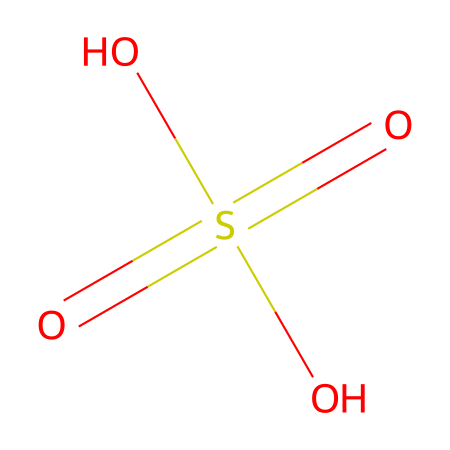What is the name of this chemical? The SMILES representation corresponds to the structural formula of sulfuric acid, which is well-known in chemistry.
Answer: sulfuric acid How many oxygen atoms are present in this chemical? Analyzing the SMILES, there are four oxygen atoms indicated (O= and O- in the representation).
Answer: four What is the total number of hydrogen atoms in this chemical? The structure shows two hydroxyl groups (–OH), which indicates there are two hydrogen atoms connected to the oxygen atoms in addition to the oxygens already present.
Answer: two What type of acid is represented by this chemical? The presence of multiple oxygen atoms bonded to sulfur and the hydroxyl groups indicates that this is a strong mineral acid known for its corrosive properties.
Answer: strong acid How does the presence of sulfur affect the reactivity of this chemical? Sulfur typically forms strong bonds with oxygen, leading to high acidity and reactivity; the SO4 structure shows this reactive capability.
Answer: increases reactivity What is this chemical commonly used for in industry? This acid is extensively utilized in several industrial applications including cleaning processes and manufacturing, due to its strong dehydrating properties.
Answer: cleaning processes What safety measures are essential when handling this chemical? Given its corrosive nature, it is critical to wear personal protective equipment (PPE), such as gloves and goggles, when handling sulfuric acid to prevent burns.
Answer: PPE required 